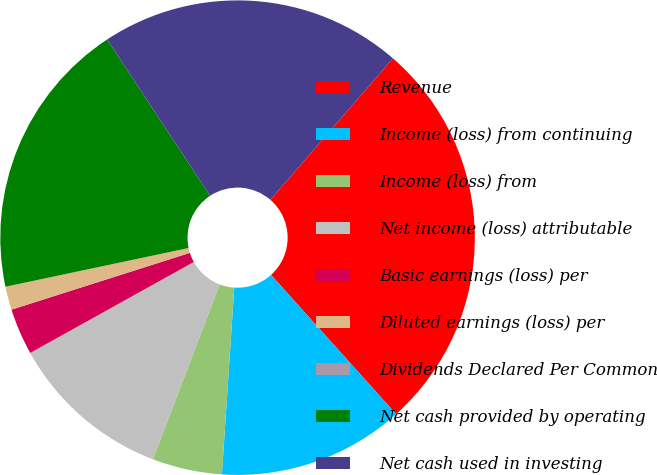Convert chart. <chart><loc_0><loc_0><loc_500><loc_500><pie_chart><fcel>Revenue<fcel>Income (loss) from continuing<fcel>Income (loss) from<fcel>Net income (loss) attributable<fcel>Basic earnings (loss) per<fcel>Diluted earnings (loss) per<fcel>Dividends Declared Per Common<fcel>Net cash provided by operating<fcel>Net cash used in investing<nl><fcel>26.98%<fcel>12.7%<fcel>4.76%<fcel>11.11%<fcel>3.17%<fcel>1.59%<fcel>0.0%<fcel>19.05%<fcel>20.63%<nl></chart> 